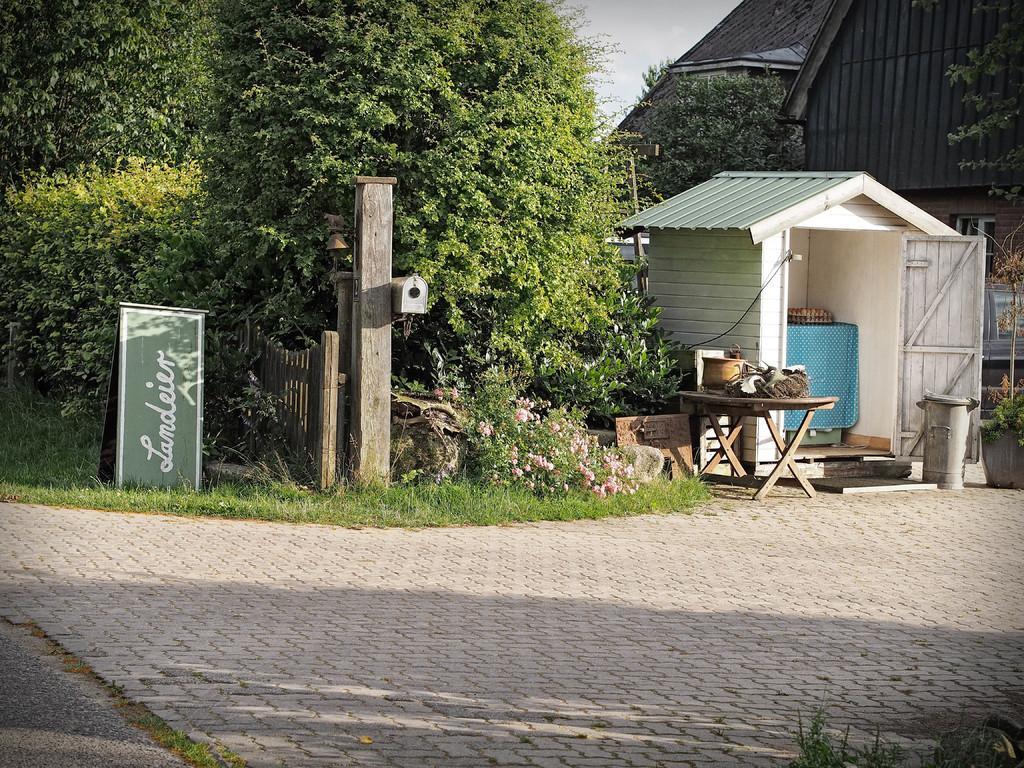Describe this image in one or two sentences. At the bottom of the image there is a floor. Behind the floor there is a wooden fencing, table with few items and also there is a name board. On the right side of the image there is a small room with few items in it. Behind that room there is a house with walls and roofs. And in the background there are trees. 